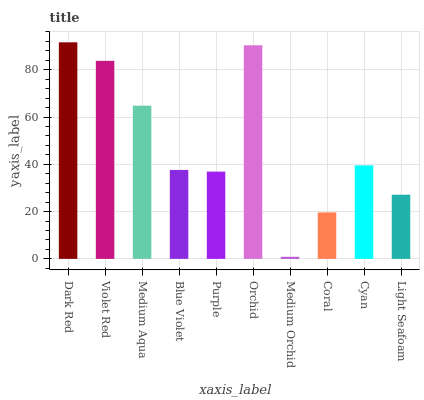Is Medium Orchid the minimum?
Answer yes or no. Yes. Is Dark Red the maximum?
Answer yes or no. Yes. Is Violet Red the minimum?
Answer yes or no. No. Is Violet Red the maximum?
Answer yes or no. No. Is Dark Red greater than Violet Red?
Answer yes or no. Yes. Is Violet Red less than Dark Red?
Answer yes or no. Yes. Is Violet Red greater than Dark Red?
Answer yes or no. No. Is Dark Red less than Violet Red?
Answer yes or no. No. Is Cyan the high median?
Answer yes or no. Yes. Is Blue Violet the low median?
Answer yes or no. Yes. Is Purple the high median?
Answer yes or no. No. Is Medium Orchid the low median?
Answer yes or no. No. 